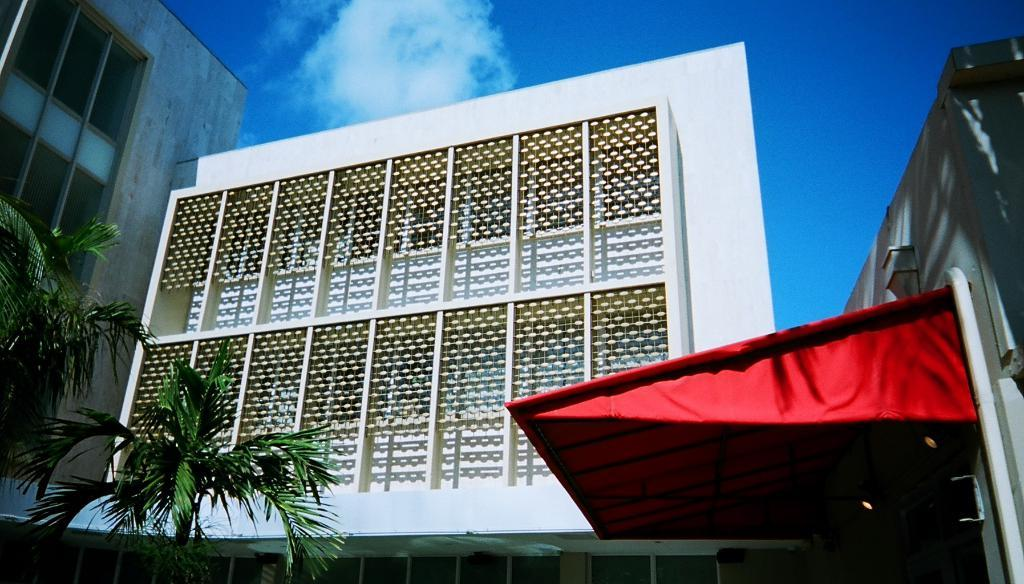What type of structures can be seen in the image? There are buildings in the image. What type of vegetation is present in the image? There are trees in the image. What type of small structure can be seen in the image? There is a shed in the image. What is visible in the background of the image? The sky is visible in the image. Can you hear the harmony of the geese flying in the image? There are no geese present in the image, so it is not possible to hear their harmony. 